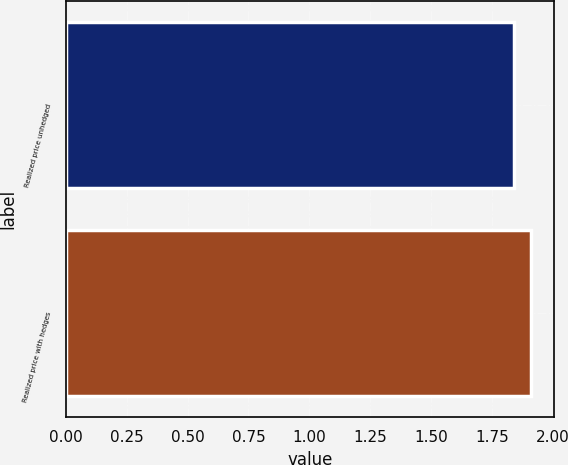<chart> <loc_0><loc_0><loc_500><loc_500><bar_chart><fcel>Realized price unhedged<fcel>Realized price with hedges<nl><fcel>1.84<fcel>1.91<nl></chart> 